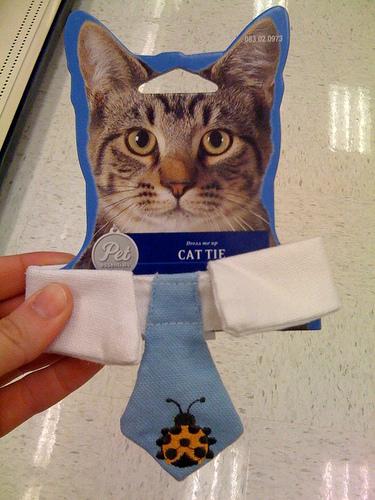Is this tie for a domestic animal?
Short answer required. Yes. Is this an advertisement of a pet store?
Answer briefly. No. What insect is printed on the tie?
Concise answer only. Ladybug. 